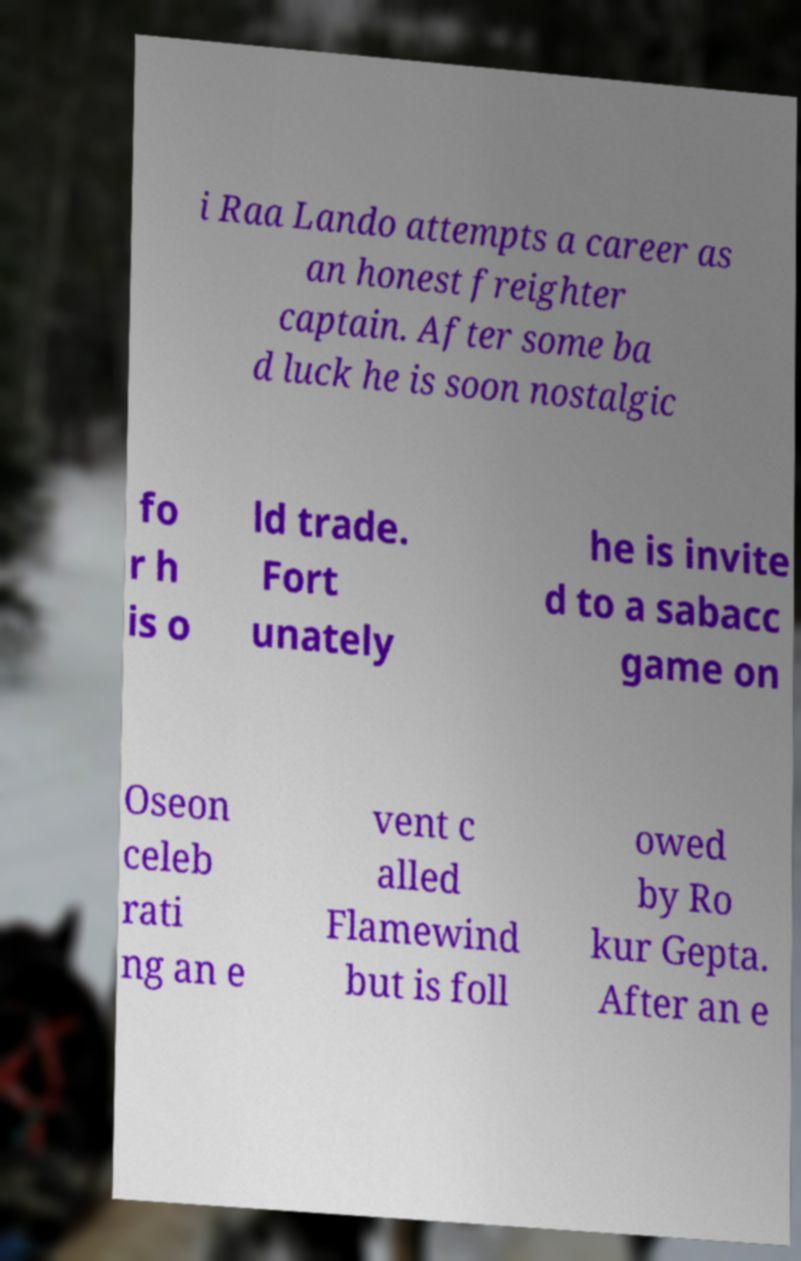I need the written content from this picture converted into text. Can you do that? i Raa Lando attempts a career as an honest freighter captain. After some ba d luck he is soon nostalgic fo r h is o ld trade. Fort unately he is invite d to a sabacc game on Oseon celeb rati ng an e vent c alled Flamewind but is foll owed by Ro kur Gepta. After an e 